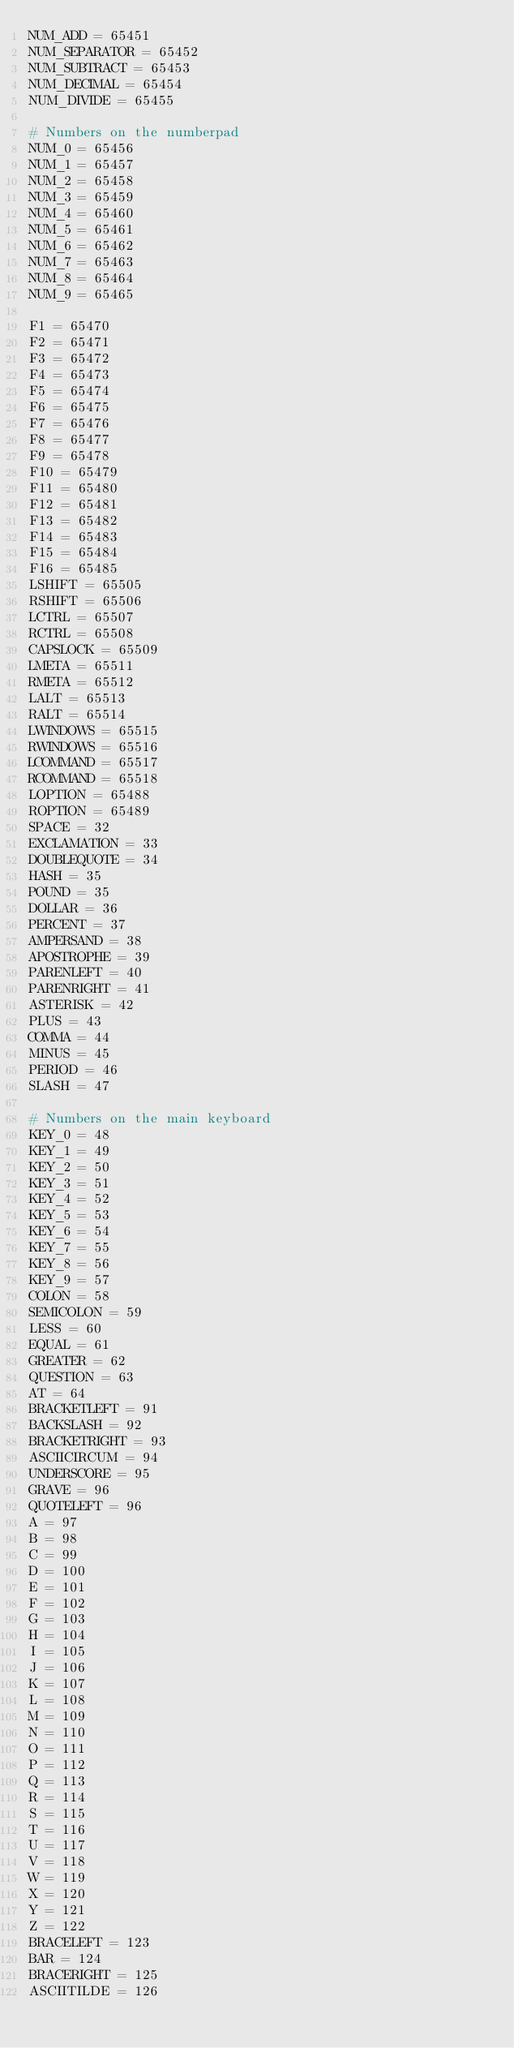Convert code to text. <code><loc_0><loc_0><loc_500><loc_500><_Python_>NUM_ADD = 65451
NUM_SEPARATOR = 65452
NUM_SUBTRACT = 65453
NUM_DECIMAL = 65454
NUM_DIVIDE = 65455

# Numbers on the numberpad
NUM_0 = 65456
NUM_1 = 65457
NUM_2 = 65458
NUM_3 = 65459
NUM_4 = 65460
NUM_5 = 65461
NUM_6 = 65462
NUM_7 = 65463
NUM_8 = 65464
NUM_9 = 65465

F1 = 65470
F2 = 65471
F3 = 65472
F4 = 65473
F5 = 65474
F6 = 65475
F7 = 65476
F8 = 65477
F9 = 65478
F10 = 65479
F11 = 65480
F12 = 65481
F13 = 65482
F14 = 65483
F15 = 65484
F16 = 65485
LSHIFT = 65505
RSHIFT = 65506
LCTRL = 65507
RCTRL = 65508
CAPSLOCK = 65509
LMETA = 65511
RMETA = 65512
LALT = 65513
RALT = 65514
LWINDOWS = 65515
RWINDOWS = 65516
LCOMMAND = 65517
RCOMMAND = 65518
LOPTION = 65488
ROPTION = 65489
SPACE = 32
EXCLAMATION = 33
DOUBLEQUOTE = 34
HASH = 35
POUND = 35
DOLLAR = 36
PERCENT = 37
AMPERSAND = 38
APOSTROPHE = 39
PARENLEFT = 40
PARENRIGHT = 41
ASTERISK = 42
PLUS = 43
COMMA = 44
MINUS = 45
PERIOD = 46
SLASH = 47

# Numbers on the main keyboard
KEY_0 = 48
KEY_1 = 49
KEY_2 = 50
KEY_3 = 51
KEY_4 = 52
KEY_5 = 53
KEY_6 = 54
KEY_7 = 55
KEY_8 = 56
KEY_9 = 57
COLON = 58
SEMICOLON = 59
LESS = 60
EQUAL = 61
GREATER = 62
QUESTION = 63
AT = 64
BRACKETLEFT = 91
BACKSLASH = 92
BRACKETRIGHT = 93
ASCIICIRCUM = 94
UNDERSCORE = 95
GRAVE = 96
QUOTELEFT = 96
A = 97
B = 98
C = 99
D = 100
E = 101
F = 102
G = 103
H = 104
I = 105
J = 106
K = 107
L = 108
M = 109
N = 110
O = 111
P = 112
Q = 113
R = 114
S = 115
T = 116
U = 117
V = 118
W = 119
X = 120
Y = 121
Z = 122
BRACELEFT = 123
BAR = 124
BRACERIGHT = 125
ASCIITILDE = 126
</code> 